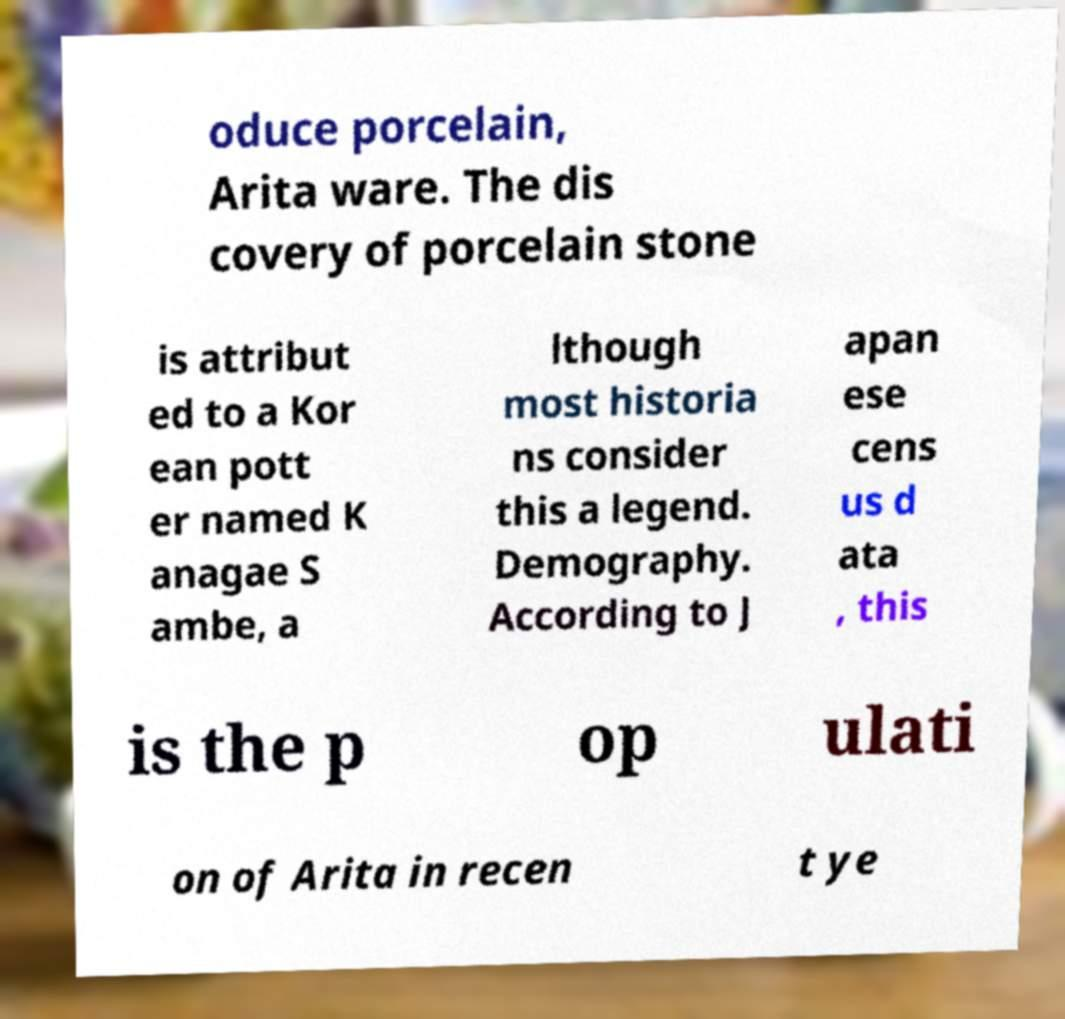Please identify and transcribe the text found in this image. oduce porcelain, Arita ware. The dis covery of porcelain stone is attribut ed to a Kor ean pott er named K anagae S ambe, a lthough most historia ns consider this a legend. Demography. According to J apan ese cens us d ata , this is the p op ulati on of Arita in recen t ye 